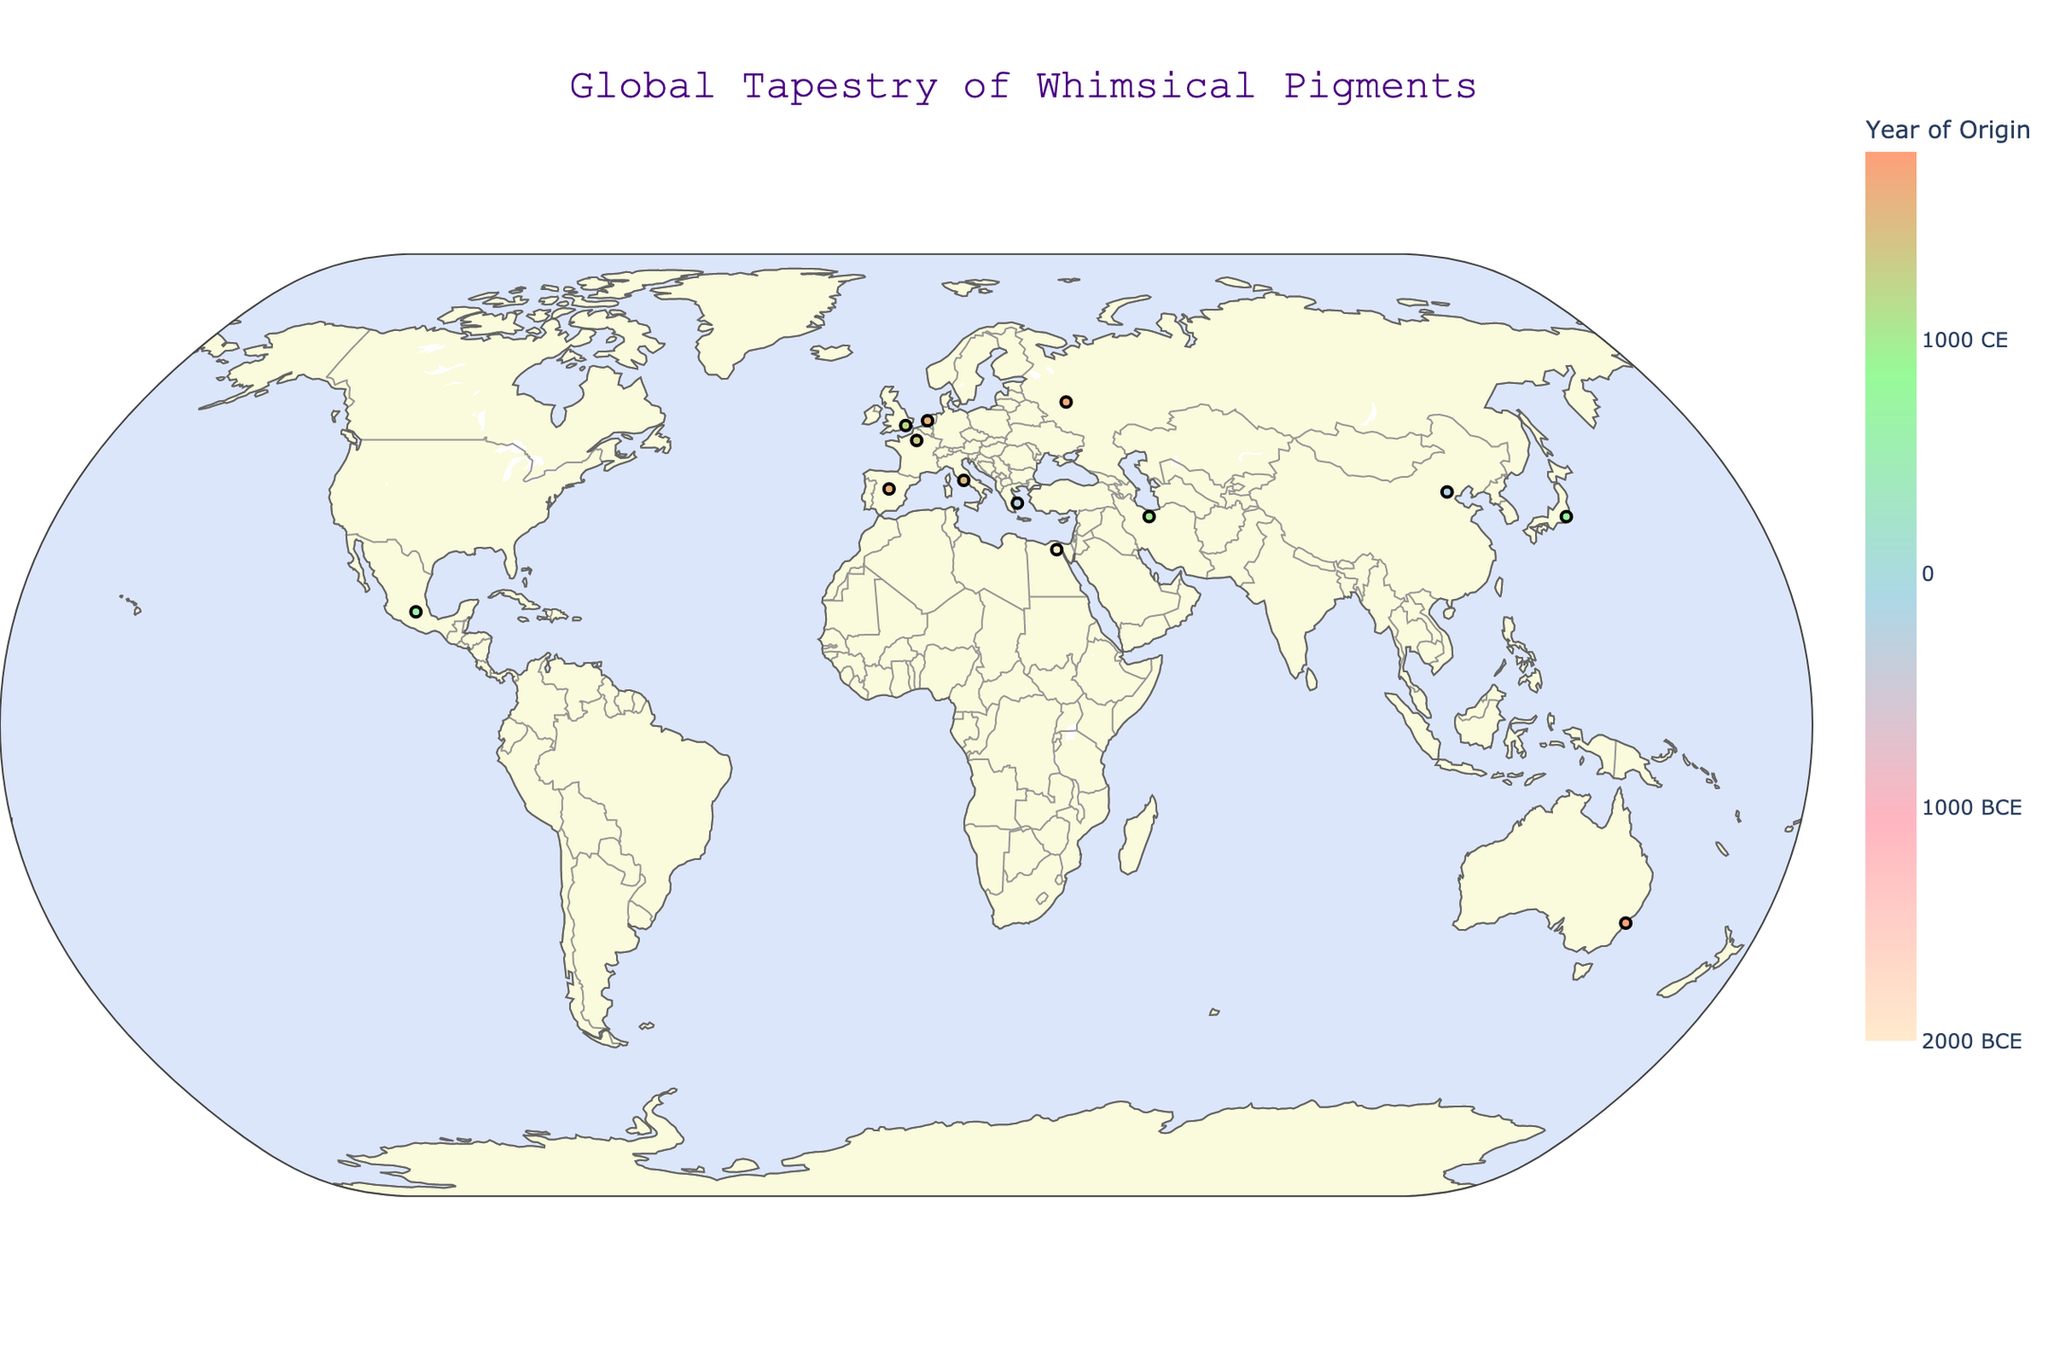What is the title of the geographic plot? The title is typically displayed prominently at the top of the plot. In this case, it reads "Global Tapestry of Whimsical Pigments."
Answer: Global Tapestry of Whimsical Pigments What does the color scale represent on the plot? The color scale on the right side of the plot represents the "Year of Origin" of each pigment. The scale is marked with years ranging from 2000 BCE to 2000 CE.
Answer: Year of Origin Which pigment is associated with whispers of ancient fire-breathing lizards, and where is it from? By referring to the hover information for each data point, the whimsical description "whispers of ancient fire-breathing lizards" corresponds to "Dragon's Blood Red," originating from Japan.
Answer: Dragon's Blood Red, Japan Between Egyptian Blue and Han Purple, which one originated earlier? By comparing the years provided in the hover information of each pigment, "Egyptian Blue" originated around 2000 BCE, whereas "Han Purple" originated around 200 BCE.
Answer: Egyptian Blue What is the approximate latitude and longitude of the pigment "Maya Blue"? The positional data on the plot indicates "Maya Blue" is located at approximately 19.4326 latitude and -99.1332 longitude.
Answer: 19.4326, -99.1332 Which pigments originated before 0 CE and what are their whimsical descriptions? By reviewing the hover information and the color scale, we identify the pigments and their whimsical descriptions:
- "Egyptian Blue" originates around 2000 BCE: "Nile's tears crystallized under Ra's gaze."
- "Vermilion" originates around 300 BCE: “Hermes' swift footprints across Mount Olympus.”
- "Han Purple" originates around 200 BCE: “Emperors' whispers captured in crystalline form.”
Answer: Egyptian Blue: Nile's tears crystallized under Ra's gaze; Vermilion: Hermes' swift footprints across Mount Olympus; Han Purple: Emperors' whispers captured in crystalline form How many pigments are represented on the plot? By counting the number of data points, each representing a pigment on the plot, we find there are 13 pigments in total.
Answer: 13 Which pigment has the most recent origin, and where is it located? By referring to the hover information and the color scale, "Gamboge" has the most recent origin around 1800 CE and is located in Australia.
Answer: Gamboge, Australia What is the common element in the whimsical descriptions of pigments originating in Italy and France? The pigments originating in Italy and France are "Vatican Purple" and "Lapis Lazuli Blue," respectively. Both descriptions evoke a celestial or divine aspect: "Papal robes dipped in grape juice dreams" (Italy) and "Sky fragments smuggled from heaven's vault" (France).
Answer: Celestial or divine aspect 